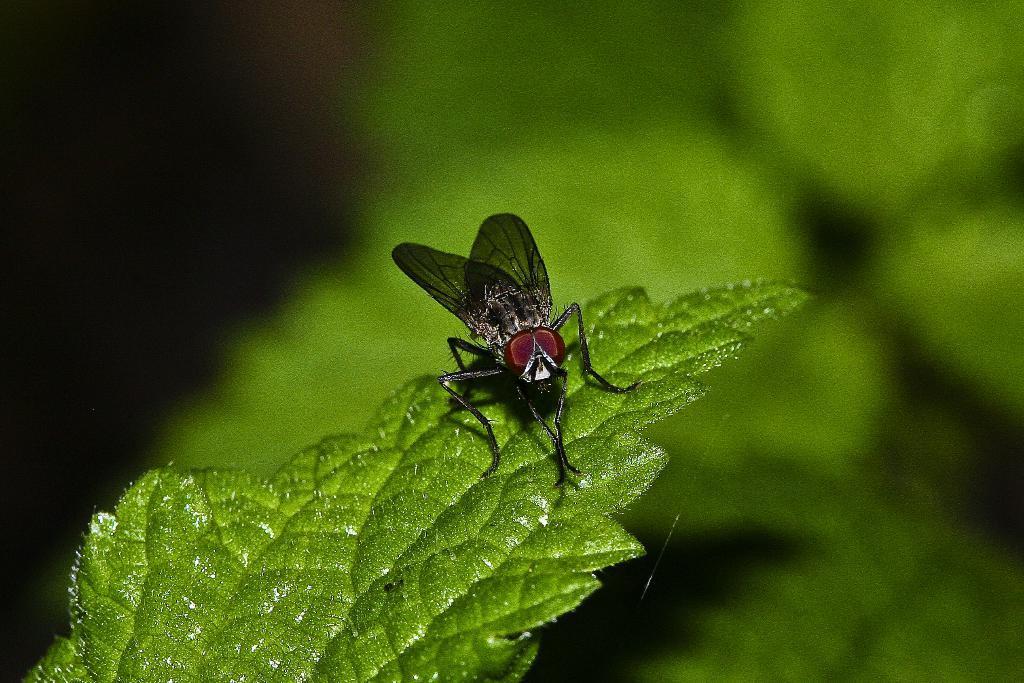Describe this image in one or two sentences. In this picture we can see a black color bug is sitting on the green leave. Behind there is a blur background. 